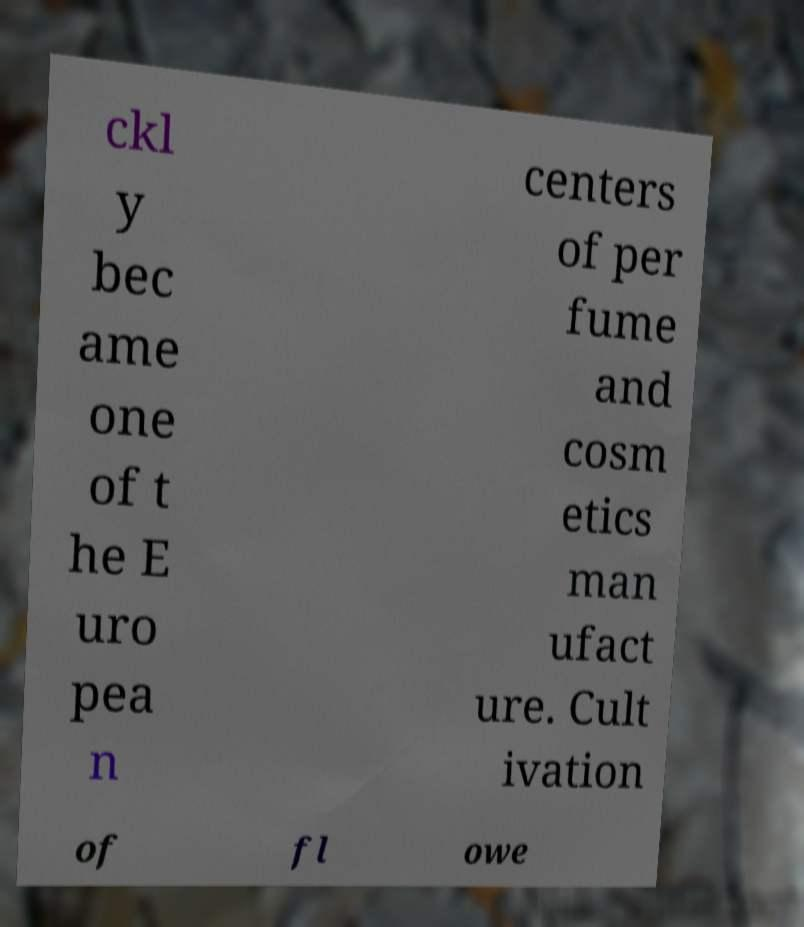Can you read and provide the text displayed in the image?This photo seems to have some interesting text. Can you extract and type it out for me? ckl y bec ame one of t he E uro pea n centers of per fume and cosm etics man ufact ure. Cult ivation of fl owe 